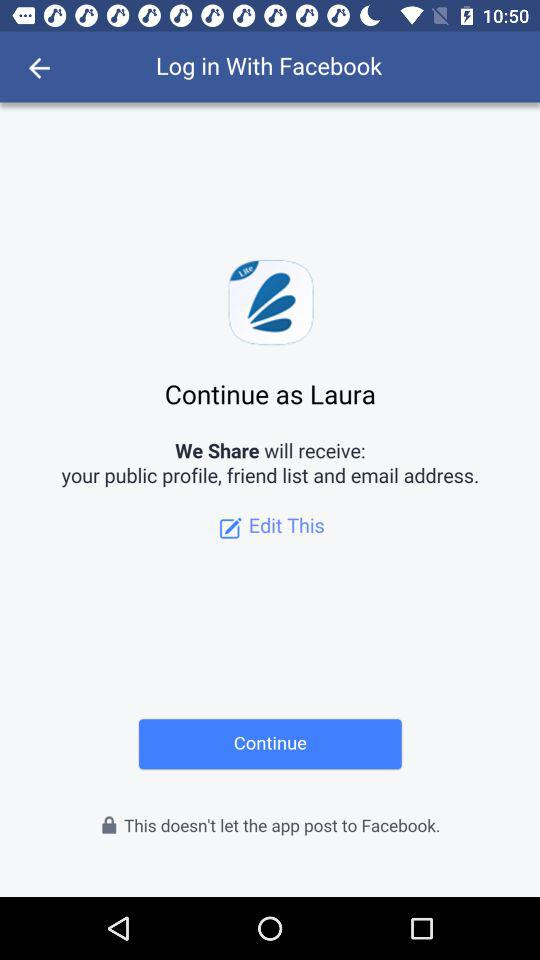What account am I using for login? You are using "Facebook" for login. 